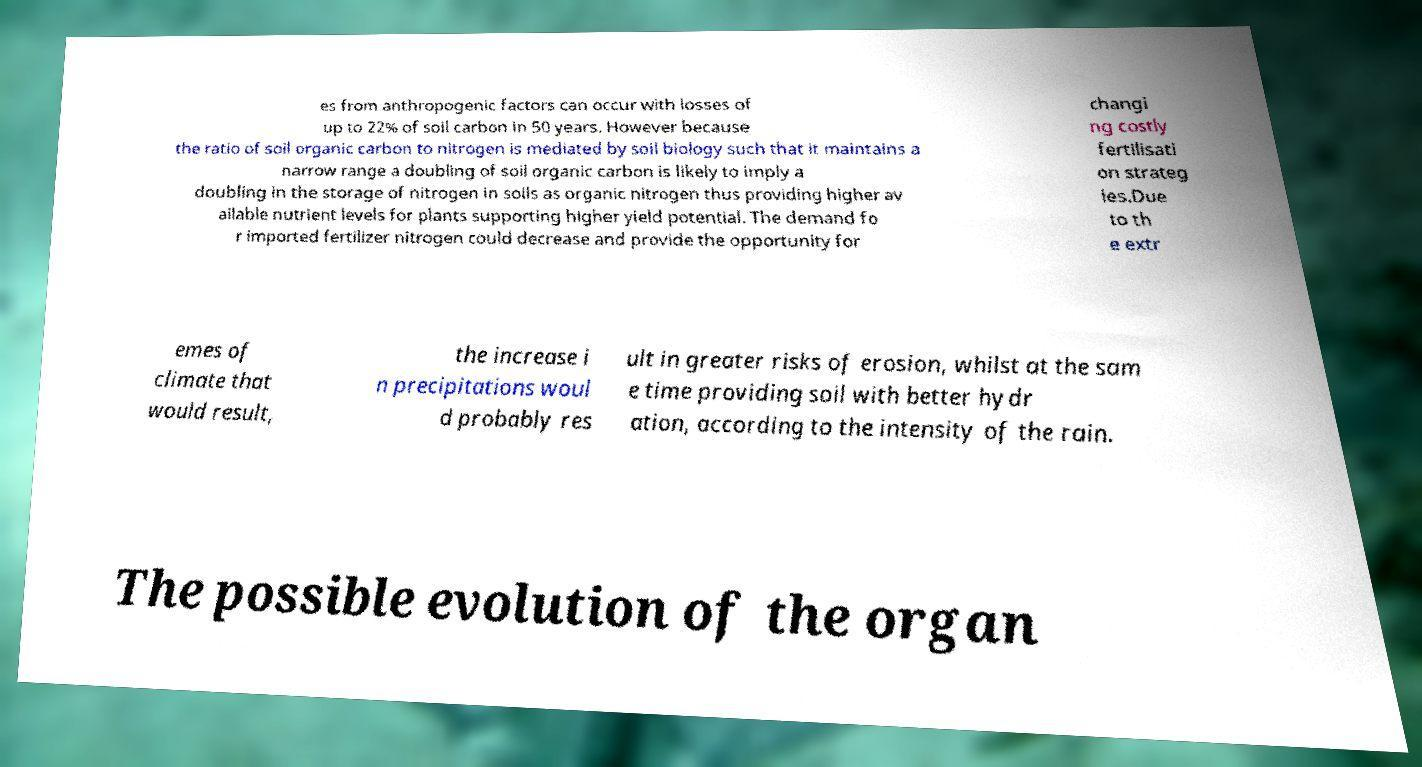Please read and relay the text visible in this image. What does it say? es from anthropogenic factors can occur with losses of up to 22% of soil carbon in 50 years. However because the ratio of soil organic carbon to nitrogen is mediated by soil biology such that it maintains a narrow range a doubling of soil organic carbon is likely to imply a doubling in the storage of nitrogen in soils as organic nitrogen thus providing higher av ailable nutrient levels for plants supporting higher yield potential. The demand fo r imported fertilizer nitrogen could decrease and provide the opportunity for changi ng costly fertilisati on strateg ies.Due to th e extr emes of climate that would result, the increase i n precipitations woul d probably res ult in greater risks of erosion, whilst at the sam e time providing soil with better hydr ation, according to the intensity of the rain. The possible evolution of the organ 